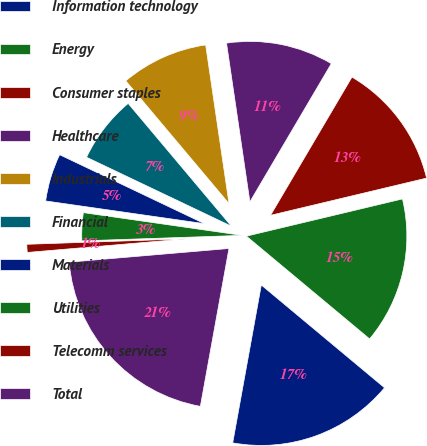Convert chart to OTSL. <chart><loc_0><loc_0><loc_500><loc_500><pie_chart><fcel>Information technology<fcel>Energy<fcel>Consumer staples<fcel>Healthcare<fcel>Industrials<fcel>Financial<fcel>Materials<fcel>Utilities<fcel>Telecomm services<fcel>Total<nl><fcel>16.79%<fcel>14.79%<fcel>12.8%<fcel>10.8%<fcel>8.8%<fcel>6.8%<fcel>4.81%<fcel>2.81%<fcel>0.81%<fcel>20.79%<nl></chart> 